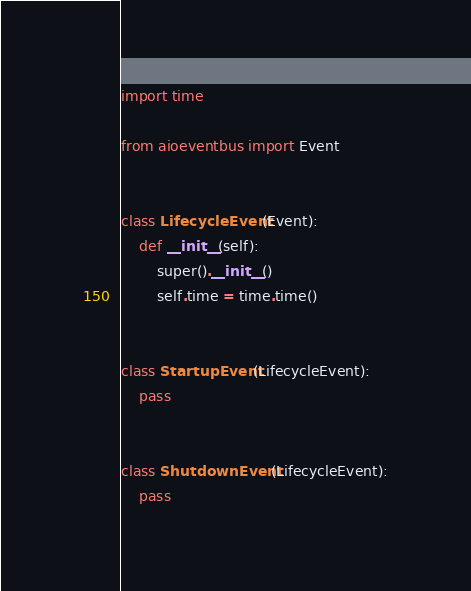Convert code to text. <code><loc_0><loc_0><loc_500><loc_500><_Python_>import time

from aioeventbus import Event


class LifecycleEvent(Event):
    def __init__(self):
        super().__init__()
        self.time = time.time()


class StartupEvent(LifecycleEvent):
    pass


class ShutdownEvent(LifecycleEvent):
    pass
</code> 